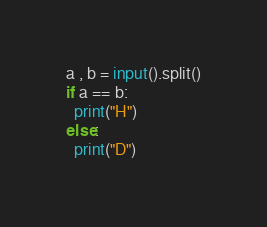<code> <loc_0><loc_0><loc_500><loc_500><_Python_>a , b = input().split()
if a == b:
  print("H")
else:
  print("D")</code> 